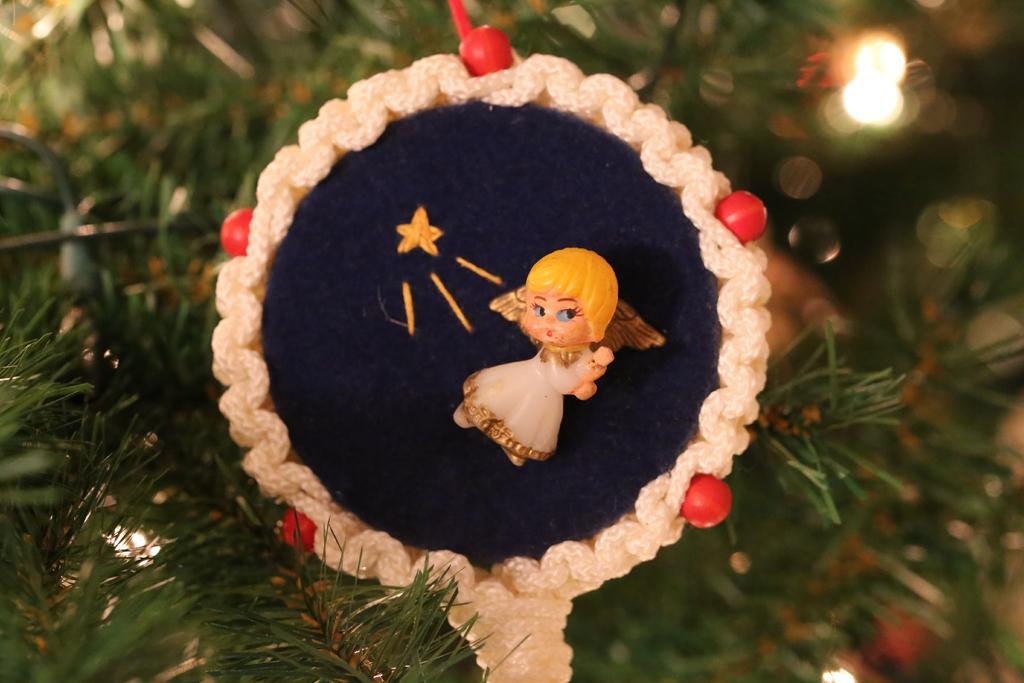Can you describe this image briefly? In this image there is a Christmas tree in the middle. On the tree there is some decorative item on which there is a small doll. 